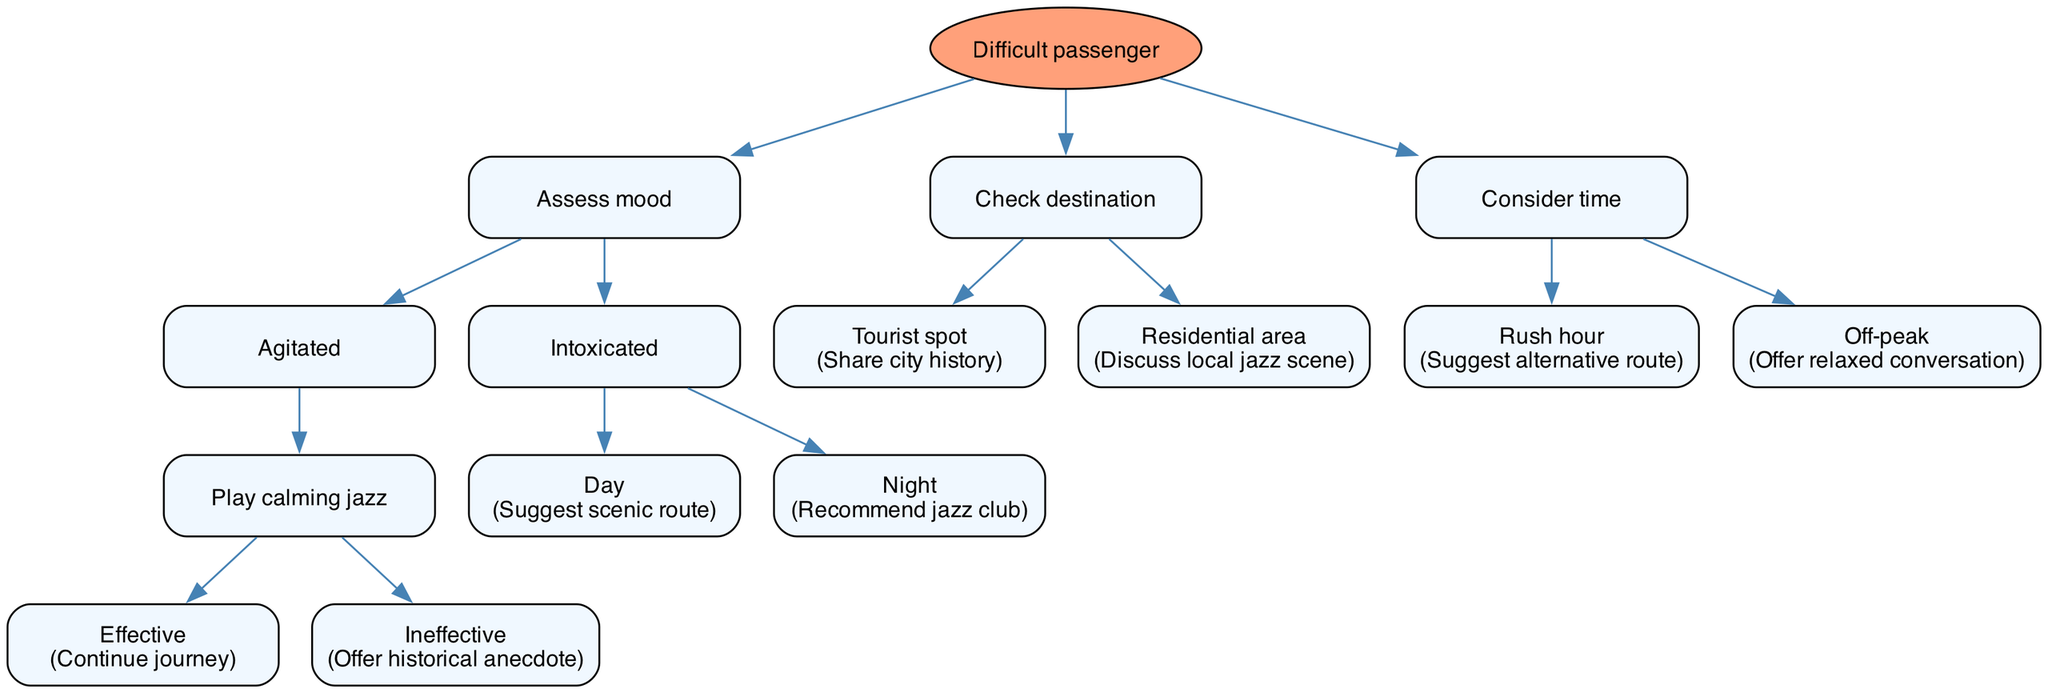What is the root node of the decision tree? The root node is explicitly stated in the provided data as "Difficult passenger." Therefore, this information can be directly accessed without following the paths of the tree.
Answer: Difficult passenger How many main nodes are there under the root node? The root has three main nodes: "Assess mood," "Check destination," and "Consider time." Counting these gives a total of three nodes.
Answer: 3 What action should be taken if the mood is "Agitated" and playing calming jazz is ineffective? Following the path for an agitated mood, if calming jazz is ineffective, the next action prescribed is "Offer historical anecdote." This requires tracing down the agitated mood branch and its subsequent choices.
Answer: Offer historical anecdote If the destination is a tourist spot, what should be done? The decision tree clearly states that when the destination is a "Tourist spot," the action is to "Share city history." This follows the direct path from the "Check destination" node to its child.
Answer: Share city history During what time of day should you recommend a jazz club for an intoxicated passenger? In the decision tree, if the passenger is classified as intoxicated, the action to recommend a jazz club is specified for the "Night." This involves understanding the link of the intoxicated node to day and night options.
Answer: Night What action is recommended if it is rush hour? The decision tree indicates that during "Rush hour," the recommended action is to "Suggest alternative route." This comes directly from the "Consider time" node.
Answer: Suggest alternative route What happens if the mood is "Intoxicated" and it's during the day? Tracing the tree, if the passenger is intoxicated and it's daytime, the prescribed action is to "Suggest scenic route." This is derived from following the intoxicated path under the condition of daytime.
Answer: Suggest scenic route How many actions are associated with an agitated mood? Only two actions are connected to the "Agitated" mood: "Play calming jazz" and "Offer historical anecdote." This can be identified by counting the respective options under that mood's node.
Answer: 2 What is the action when the passenger's mood is intoxicated during the night? According to the decision tree, if the mood is classified as intoxicated and it is night, the recommended action is to "Recommend jazz club." This follows from the node for intoxicated conditions.
Answer: Recommend jazz club 